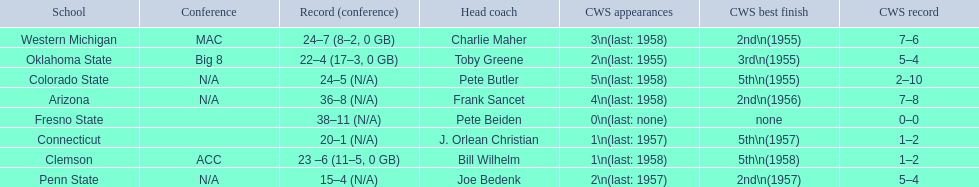What are all the schools? Arizona, Clemson, Colorado State, Connecticut, Fresno State, Oklahoma State, Penn State, Western Michigan. Which are clemson and western michigan? Clemson, Western Michigan. Of these, which has more cws appearances? Western Michigan. 